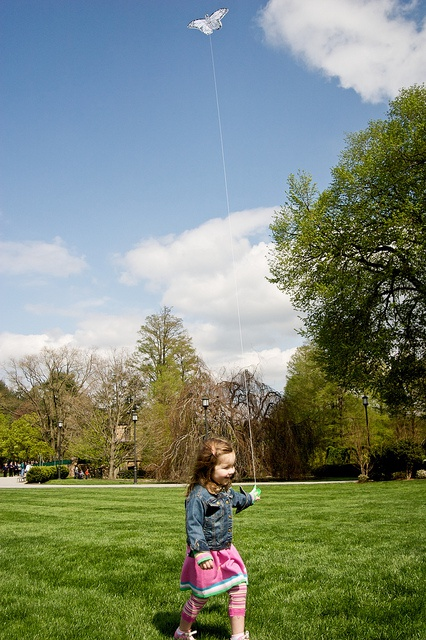Describe the objects in this image and their specific colors. I can see people in gray, black, maroon, and olive tones, kite in gray, lightgray, and darkgray tones, people in gray and black tones, people in gray, teal, darkgray, and black tones, and people in gray, black, olive, salmon, and maroon tones in this image. 